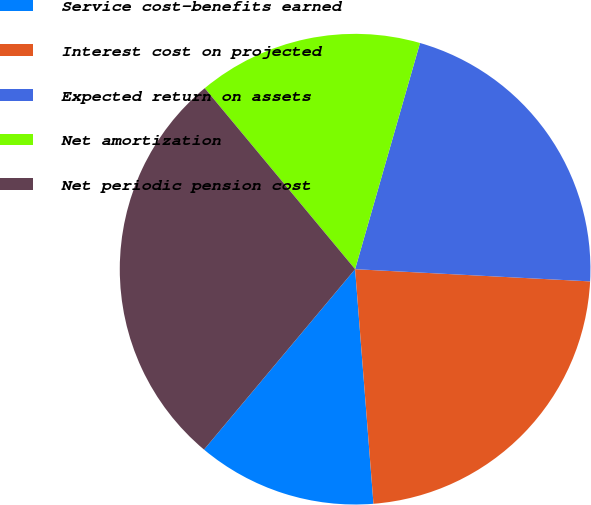Convert chart. <chart><loc_0><loc_0><loc_500><loc_500><pie_chart><fcel>Service cost-benefits earned<fcel>Interest cost on projected<fcel>Expected return on assets<fcel>Net amortization<fcel>Net periodic pension cost<nl><fcel>12.34%<fcel>22.93%<fcel>21.38%<fcel>15.48%<fcel>27.87%<nl></chart> 